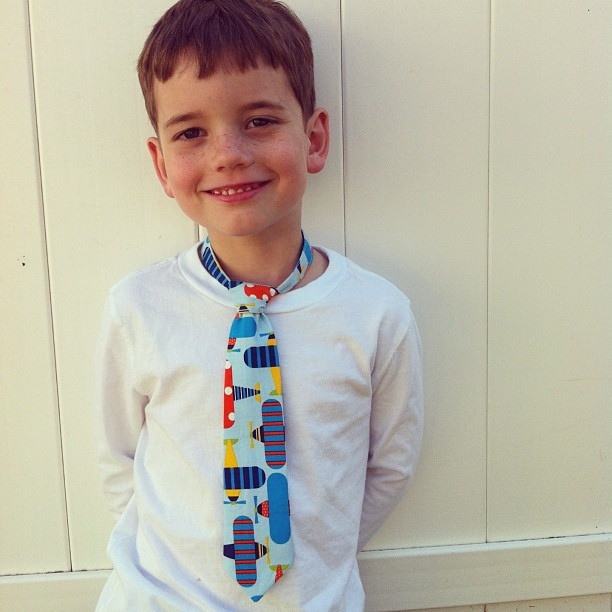Describe the objects in this image and their specific colors. I can see people in beige, lightgray, darkgray, brown, and lightblue tones and tie in beige, blue, darkgray, and lightblue tones in this image. 